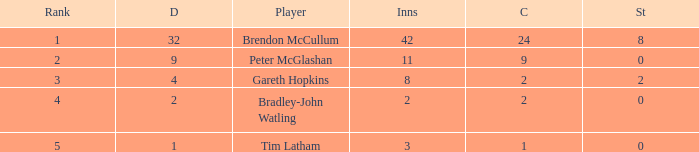What was the total number of stumpings for the player tim latham? 0.0. 